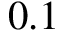Convert formula to latex. <formula><loc_0><loc_0><loc_500><loc_500>0 . 1</formula> 